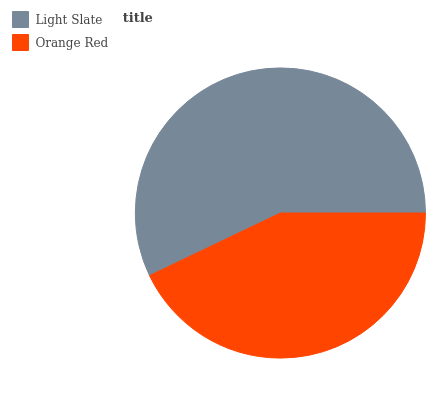Is Orange Red the minimum?
Answer yes or no. Yes. Is Light Slate the maximum?
Answer yes or no. Yes. Is Orange Red the maximum?
Answer yes or no. No. Is Light Slate greater than Orange Red?
Answer yes or no. Yes. Is Orange Red less than Light Slate?
Answer yes or no. Yes. Is Orange Red greater than Light Slate?
Answer yes or no. No. Is Light Slate less than Orange Red?
Answer yes or no. No. Is Light Slate the high median?
Answer yes or no. Yes. Is Orange Red the low median?
Answer yes or no. Yes. Is Orange Red the high median?
Answer yes or no. No. Is Light Slate the low median?
Answer yes or no. No. 